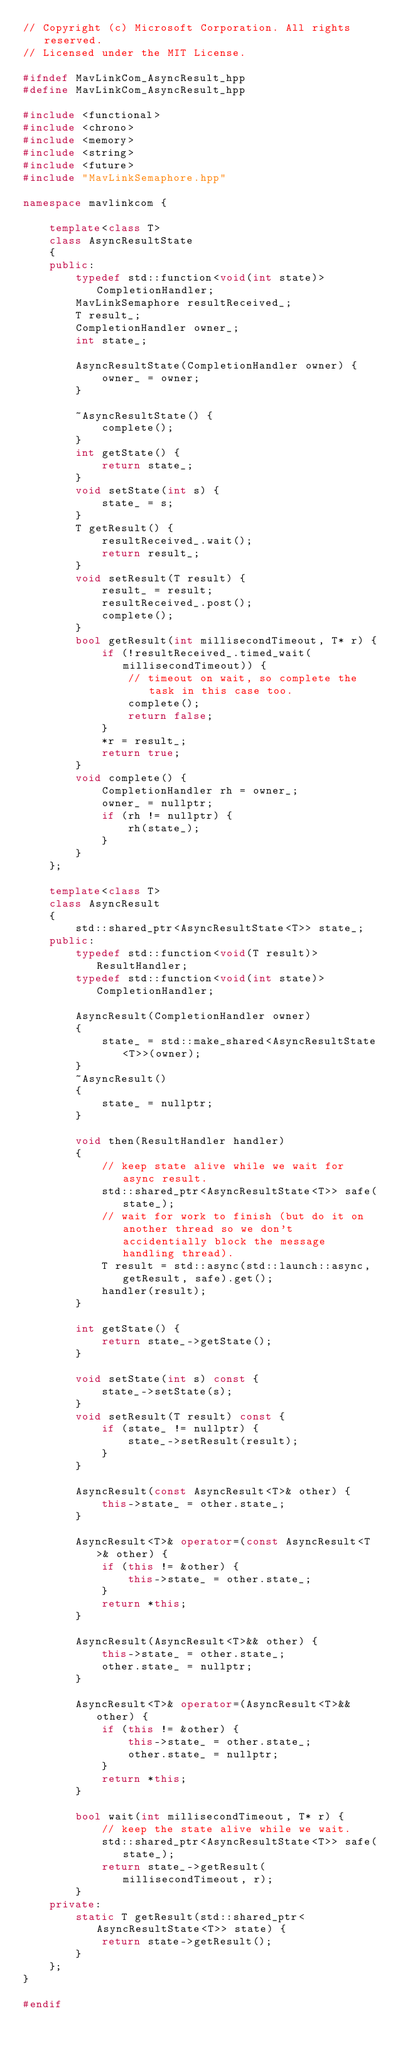<code> <loc_0><loc_0><loc_500><loc_500><_C++_>// Copyright (c) Microsoft Corporation. All rights reserved.
// Licensed under the MIT License.

#ifndef MavLinkCom_AsyncResult_hpp
#define MavLinkCom_AsyncResult_hpp

#include <functional>
#include <chrono>
#include <memory>
#include <string>
#include <future>
#include "MavLinkSemaphore.hpp"

namespace mavlinkcom {

	template<class T>
	class AsyncResultState
	{
	public:
		typedef std::function<void(int state)> CompletionHandler;
		MavLinkSemaphore resultReceived_;
		T result_;
		CompletionHandler owner_;
		int state_;

		AsyncResultState(CompletionHandler owner) {
			owner_ = owner;
		}

		~AsyncResultState() {
			complete();
		}
		int getState() {
			return state_;
		}
		void setState(int s) {
			state_ = s;
		}
		T getResult() {
			resultReceived_.wait();
			return result_;
		}
		void setResult(T result) {
			result_ = result;
			resultReceived_.post();
			complete();
		}
		bool getResult(int millisecondTimeout, T* r) {
			if (!resultReceived_.timed_wait(millisecondTimeout)) {
				// timeout on wait, so complete the task in this case too.
				complete();
				return false;
			}
			*r = result_;
			return true;
		}
		void complete() {
			CompletionHandler rh = owner_;
			owner_ = nullptr;
			if (rh != nullptr) {
				rh(state_);
			}
		}
	};

	template<class T>
	class AsyncResult 
	{
		std::shared_ptr<AsyncResultState<T>> state_;
	public:
		typedef std::function<void(T result)> ResultHandler;
		typedef std::function<void(int state)> CompletionHandler;

		AsyncResult(CompletionHandler owner)
		{
			state_ = std::make_shared<AsyncResultState<T>>(owner);
		}
		~AsyncResult() 
		{
			state_ = nullptr;
		}

		void then(ResultHandler handler)
		{
			// keep state alive while we wait for async result.
			std::shared_ptr<AsyncResultState<T>> safe(state_);
			// wait for work to finish (but do it on another thread so we don't accidentially block the message handling thread).
			T result = std::async(std::launch::async, getResult, safe).get();
			handler(result);
		}

		int getState() {
			return state_->getState();
		}

		void setState(int s) const {
			state_->setState(s);
		}
		void setResult(T result) const {
			if (state_ != nullptr) {
				state_->setResult(result);
			}
		}

		AsyncResult(const AsyncResult<T>& other) {
			this->state_ = other.state_;
		}

		AsyncResult<T>& operator=(const AsyncResult<T>& other) {
			if (this != &other) {
				this->state_ = other.state_;
			}
			return *this;
		}

		AsyncResult(AsyncResult<T>&& other) {
			this->state_ = other.state_;
			other.state_ = nullptr;
		}

		AsyncResult<T>& operator=(AsyncResult<T>&& other) {
			if (this != &other) {
				this->state_ = other.state_;
				other.state_ = nullptr;
			}
			return *this;
		}

		bool wait(int millisecondTimeout, T* r) {
			// keep the state alive while we wait.
			std::shared_ptr<AsyncResultState<T>> safe(state_);
			return state_->getResult(millisecondTimeout, r);
		}
	private:
		static T getResult(std::shared_ptr<AsyncResultState<T>> state) {
			return state->getResult();
		}
	};
}

#endif
</code> 